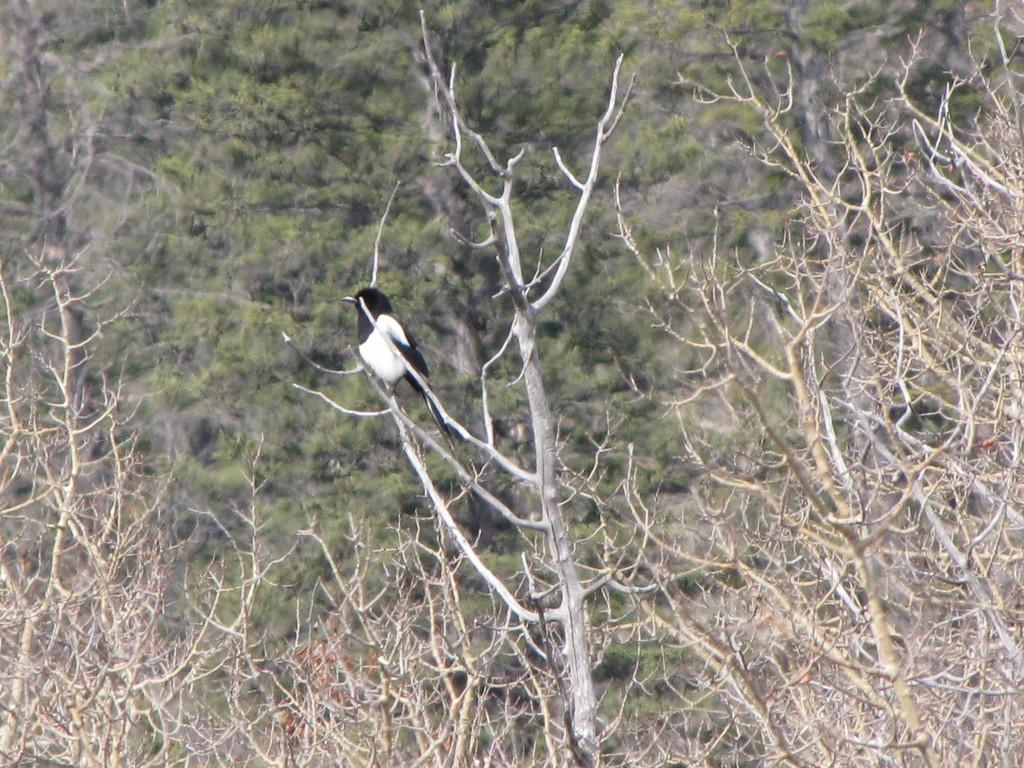What type of natural elements can be seen in the image? There are multiple trees in the image. Is there any wildlife present in the image? Yes, there is a bird on one of the trees. Can you describe the bird's appearance? The bird has a white and black color pattern. What type of boot is the man wearing in the image? There is no man or boot present in the image; it only features trees and a bird. 